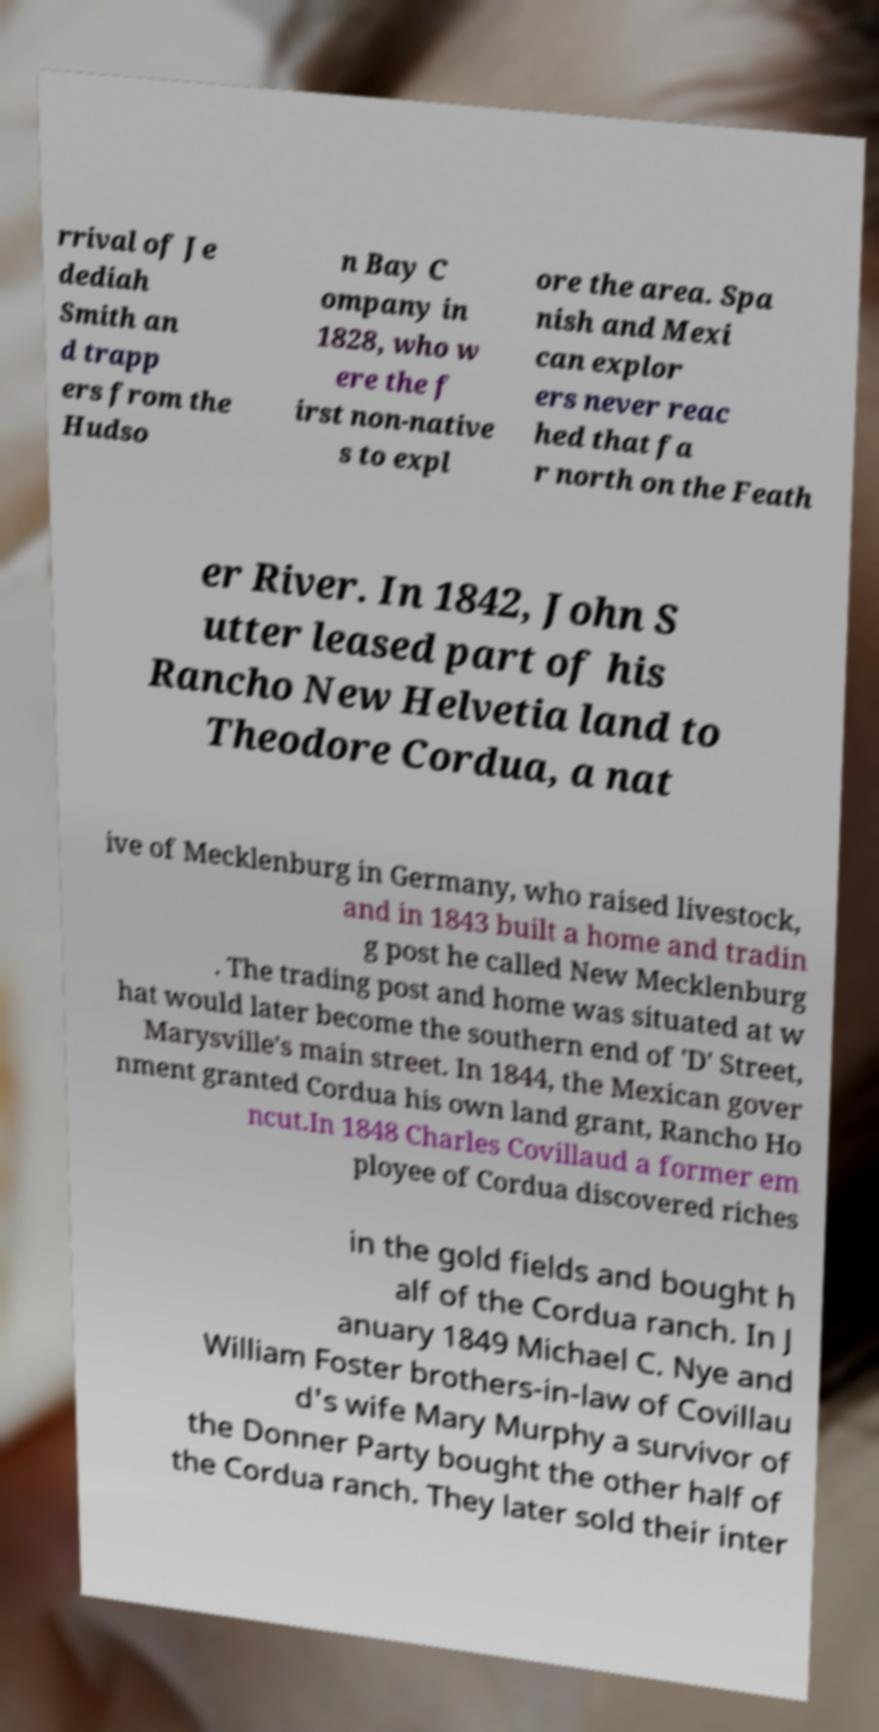What messages or text are displayed in this image? I need them in a readable, typed format. rrival of Je dediah Smith an d trapp ers from the Hudso n Bay C ompany in 1828, who w ere the f irst non-native s to expl ore the area. Spa nish and Mexi can explor ers never reac hed that fa r north on the Feath er River. In 1842, John S utter leased part of his Rancho New Helvetia land to Theodore Cordua, a nat ive of Mecklenburg in Germany, who raised livestock, and in 1843 built a home and tradin g post he called New Mecklenburg . The trading post and home was situated at w hat would later become the southern end of 'D' Street, Marysville's main street. In 1844, the Mexican gover nment granted Cordua his own land grant, Rancho Ho ncut.In 1848 Charles Covillaud a former em ployee of Cordua discovered riches in the gold fields and bought h alf of the Cordua ranch. In J anuary 1849 Michael C. Nye and William Foster brothers-in-law of Covillau d's wife Mary Murphy a survivor of the Donner Party bought the other half of the Cordua ranch. They later sold their inter 